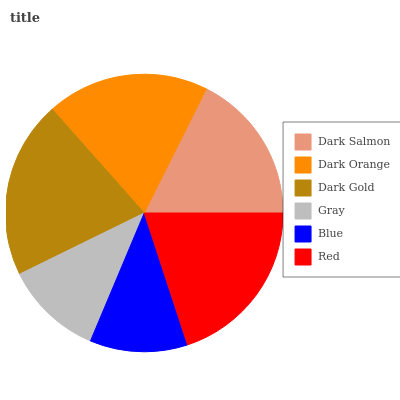Is Blue the minimum?
Answer yes or no. Yes. Is Dark Gold the maximum?
Answer yes or no. Yes. Is Dark Orange the minimum?
Answer yes or no. No. Is Dark Orange the maximum?
Answer yes or no. No. Is Dark Orange greater than Dark Salmon?
Answer yes or no. Yes. Is Dark Salmon less than Dark Orange?
Answer yes or no. Yes. Is Dark Salmon greater than Dark Orange?
Answer yes or no. No. Is Dark Orange less than Dark Salmon?
Answer yes or no. No. Is Dark Orange the high median?
Answer yes or no. Yes. Is Dark Salmon the low median?
Answer yes or no. Yes. Is Dark Salmon the high median?
Answer yes or no. No. Is Blue the low median?
Answer yes or no. No. 